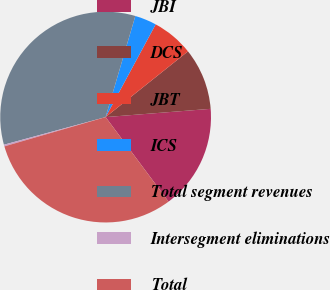<chart> <loc_0><loc_0><loc_500><loc_500><pie_chart><fcel>JBI<fcel>DCS<fcel>JBT<fcel>ICS<fcel>Total segment revenues<fcel>Intersegment eliminations<fcel>Total<nl><fcel>16.06%<fcel>9.47%<fcel>6.4%<fcel>3.33%<fcel>33.77%<fcel>0.26%<fcel>30.7%<nl></chart> 